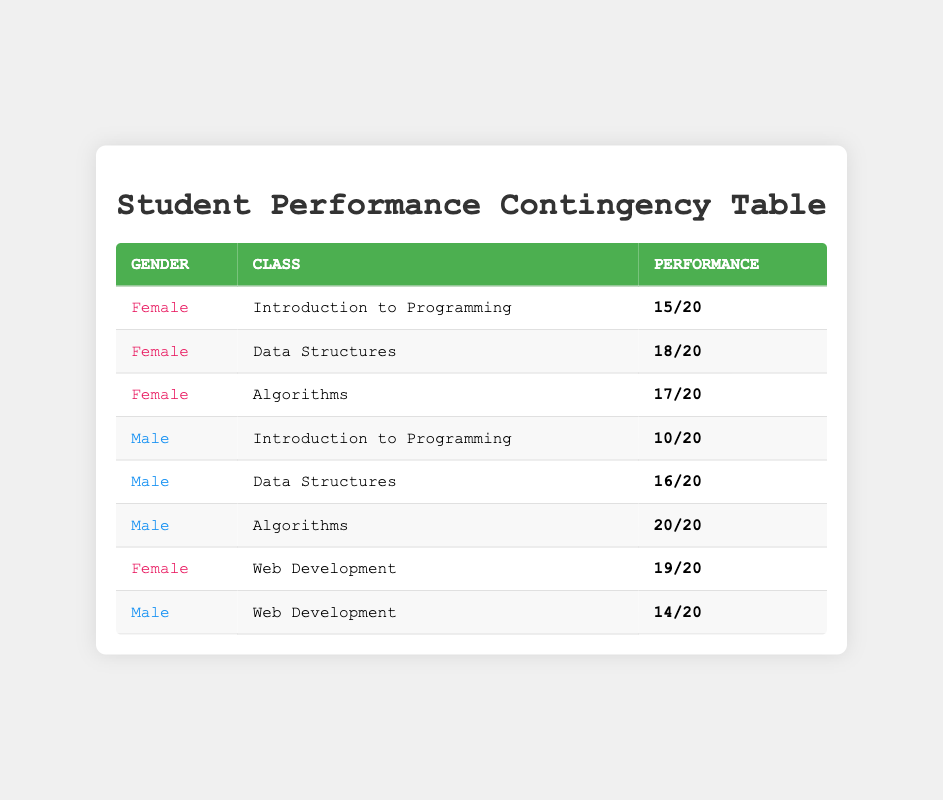What is the performance of female students in Data Structures? There is a row corresponding to female students in Data Structures with a performance of 18 out of 20.
Answer: 18/20 How many assignments did male students pass in Algorithms? The table shows that male students in Algorithms passed 20 out of 20 assignments.
Answer: 20/20 Which class had the highest performance for female students? By comparing the performance across all classes for female students, Web Development has the highest performance of 19 out of 20.
Answer: Web Development What is the average performance of male students across all classes? The performances for male students are: 10/20 (Introduction to Programming), 16/20 (Data Structures), 20/20 (Algorithms), and 14/20 (Web Development). Their average is (10 + 16 + 20 + 14) / 4 = 15.
Answer: 15 Did any female students have a performance of 100%? None of the female students had a performance of 100%, as the highest is 19 out of 20, which is not perfect.
Answer: No What is the total number of assignments passed by male students in all classes? The total assignments passed by male students are: 10 (Introduction to Programming) + 16 (Data Structures) + 20 (Algorithms) + 14 (Web Development) = 60.
Answer: 60 Comparing male and female students in Web Development, who performed better? Female students in Web Development passed 19 out of 20, while male students passed 14 out of 20, indicating females performed better.
Answer: Female students What can be inferred about the overall performance differences between genders across all classes? By observing each class performance, female students tend to have higher scores compared to male students except in Algorithms where male students achieved perfect scores.
Answer: Females perform generally better 